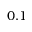<formula> <loc_0><loc_0><loc_500><loc_500>0 . 1</formula> 